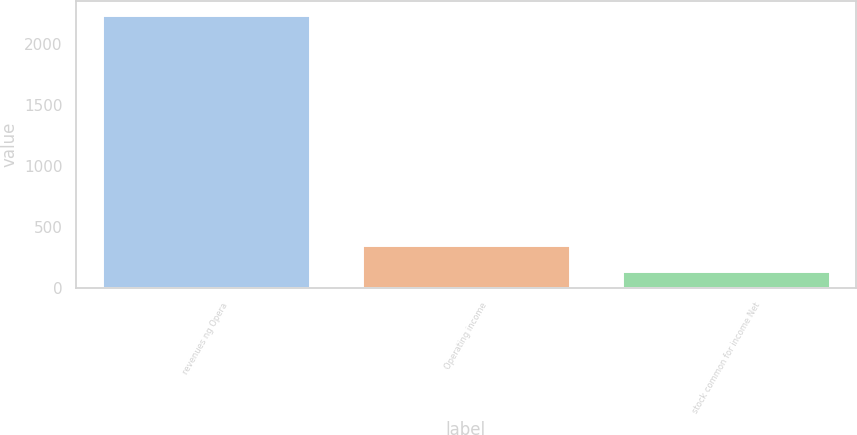Convert chart to OTSL. <chart><loc_0><loc_0><loc_500><loc_500><bar_chart><fcel>revenues ng Opera<fcel>Operating income<fcel>stock common for income Net<nl><fcel>2236<fcel>348.7<fcel>139<nl></chart> 